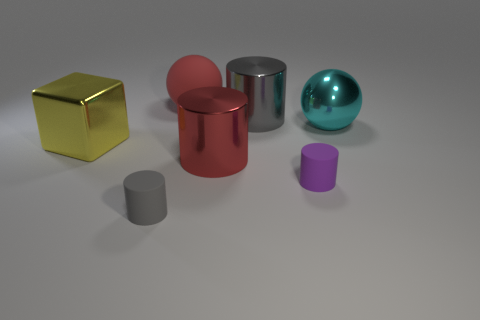Subtract all big gray shiny cylinders. How many cylinders are left? 3 Subtract all cubes. How many objects are left? 6 Add 1 red cylinders. How many objects exist? 8 Subtract all cyan balls. How many balls are left? 1 Add 2 spheres. How many spheres are left? 4 Add 6 shiny spheres. How many shiny spheres exist? 7 Subtract 1 cyan balls. How many objects are left? 6 Subtract 1 cylinders. How many cylinders are left? 3 Subtract all gray spheres. Subtract all purple cubes. How many spheres are left? 2 Subtract all blue blocks. How many red cylinders are left? 1 